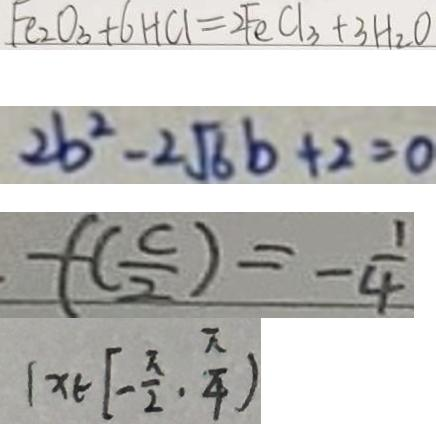<formula> <loc_0><loc_0><loc_500><loc_500>F e _ { 2 } O _ { 3 } + 6 H C l = 2 F e C l _ { 3 } + 3 H _ { 2 } O 
 2 b ^ { 2 } - 2 \sqrt { 6 } b + 2 = 0 
 f ( \frac { c } { 2 } ) = - \frac { 1 } { 4 } 
 ( x \in [ - \frac { \pi } { 2 } , \frac { \pi } { 4 } )</formula> 